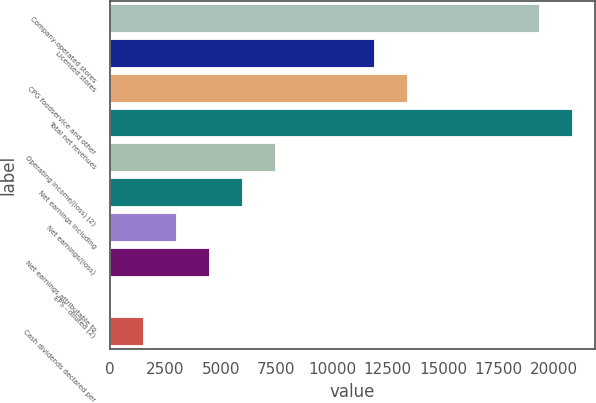Convert chart. <chart><loc_0><loc_0><loc_500><loc_500><bar_chart><fcel>Company-operated stores<fcel>Licensed stores<fcel>CPG foodservice and other<fcel>Total net revenues<fcel>Operating income/(loss) (2)<fcel>Net earnings including<fcel>Net earnings/(loss)<fcel>Net earnings attributable to<fcel>EPS - diluted (2)<fcel>Cash dividends declared per<nl><fcel>19326.8<fcel>11893.5<fcel>13380.1<fcel>20813.5<fcel>7433.41<fcel>5946.73<fcel>2973.37<fcel>4460.05<fcel>0.01<fcel>1486.69<nl></chart> 